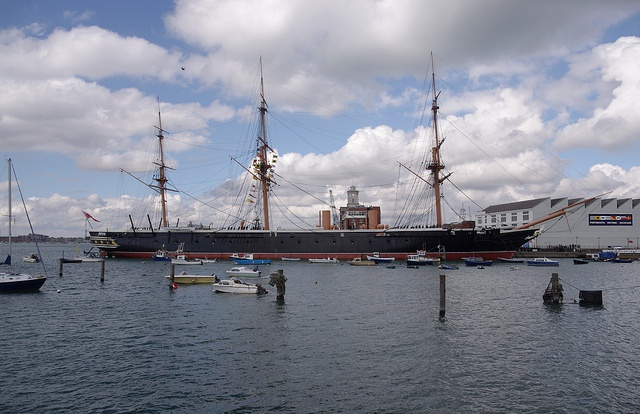Describe the objects in this image and their specific colors. I can see boat in gray, black, darkgray, and maroon tones, boat in gray, black, and darkgray tones, boat in gray, black, and darkgray tones, boat in gray, darkgray, and black tones, and boat in gray, olive, black, and darkgray tones in this image. 